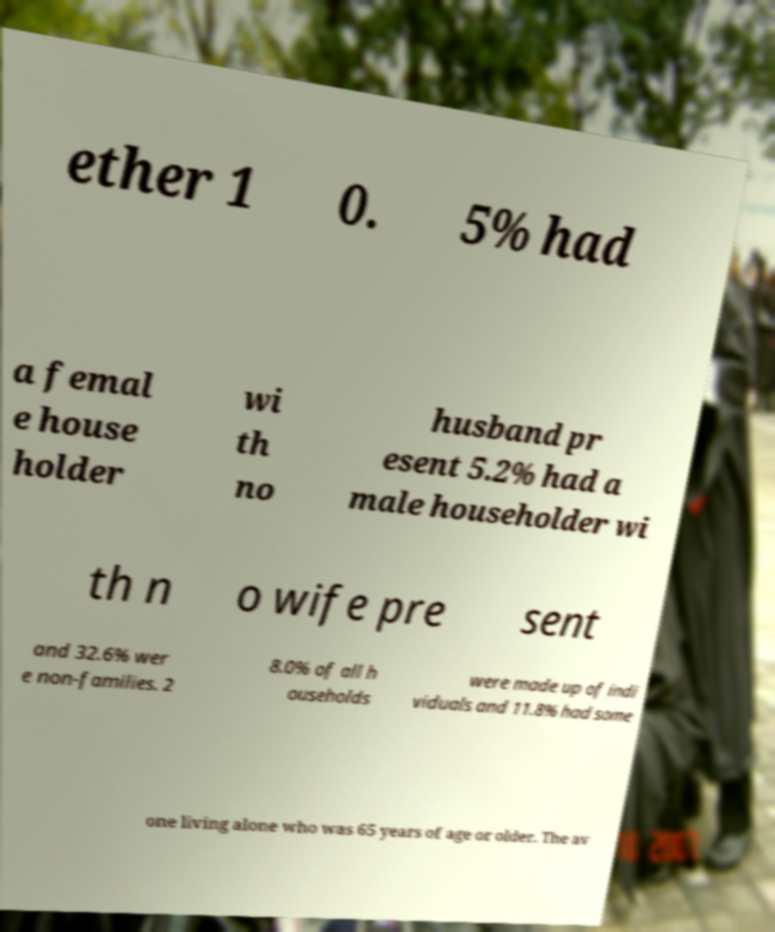Can you accurately transcribe the text from the provided image for me? ether 1 0. 5% had a femal e house holder wi th no husband pr esent 5.2% had a male householder wi th n o wife pre sent and 32.6% wer e non-families. 2 8.0% of all h ouseholds were made up of indi viduals and 11.8% had some one living alone who was 65 years of age or older. The av 